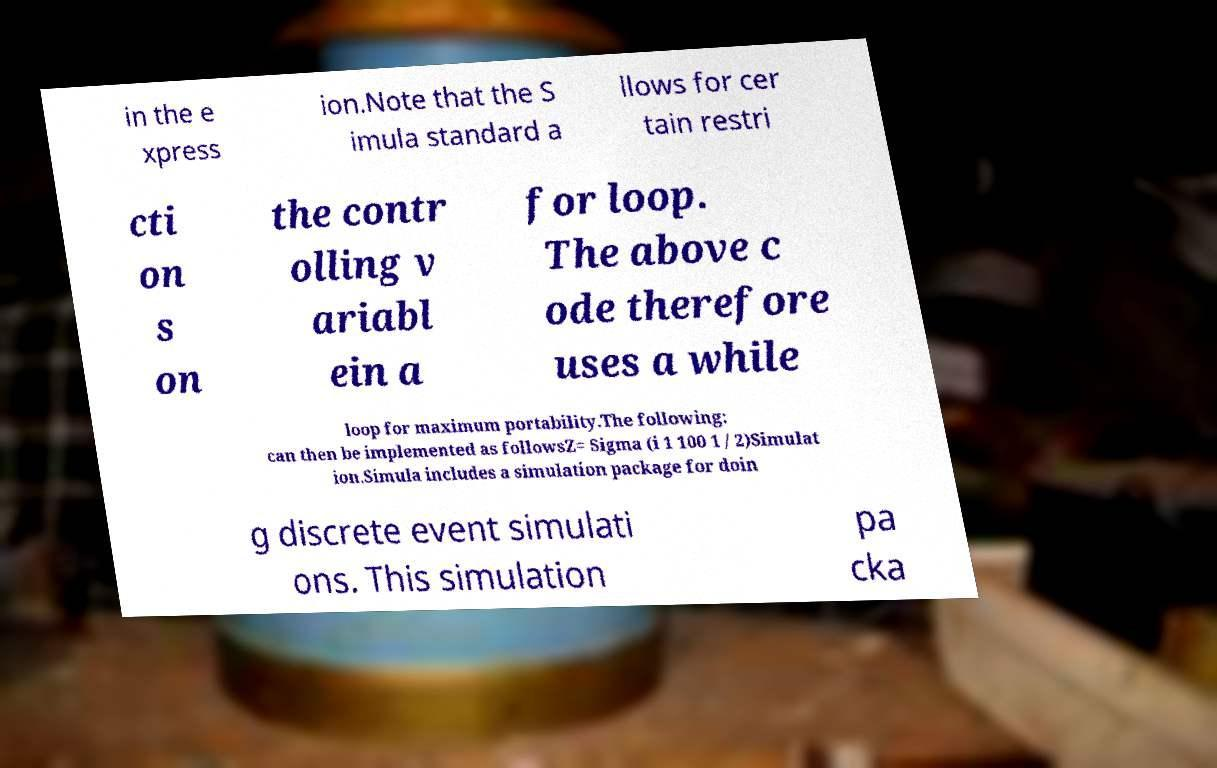There's text embedded in this image that I need extracted. Can you transcribe it verbatim? in the e xpress ion.Note that the S imula standard a llows for cer tain restri cti on s on the contr olling v ariabl ein a for loop. The above c ode therefore uses a while loop for maximum portability.The following: can then be implemented as followsZ= Sigma (i 1 100 1 / 2)Simulat ion.Simula includes a simulation package for doin g discrete event simulati ons. This simulation pa cka 